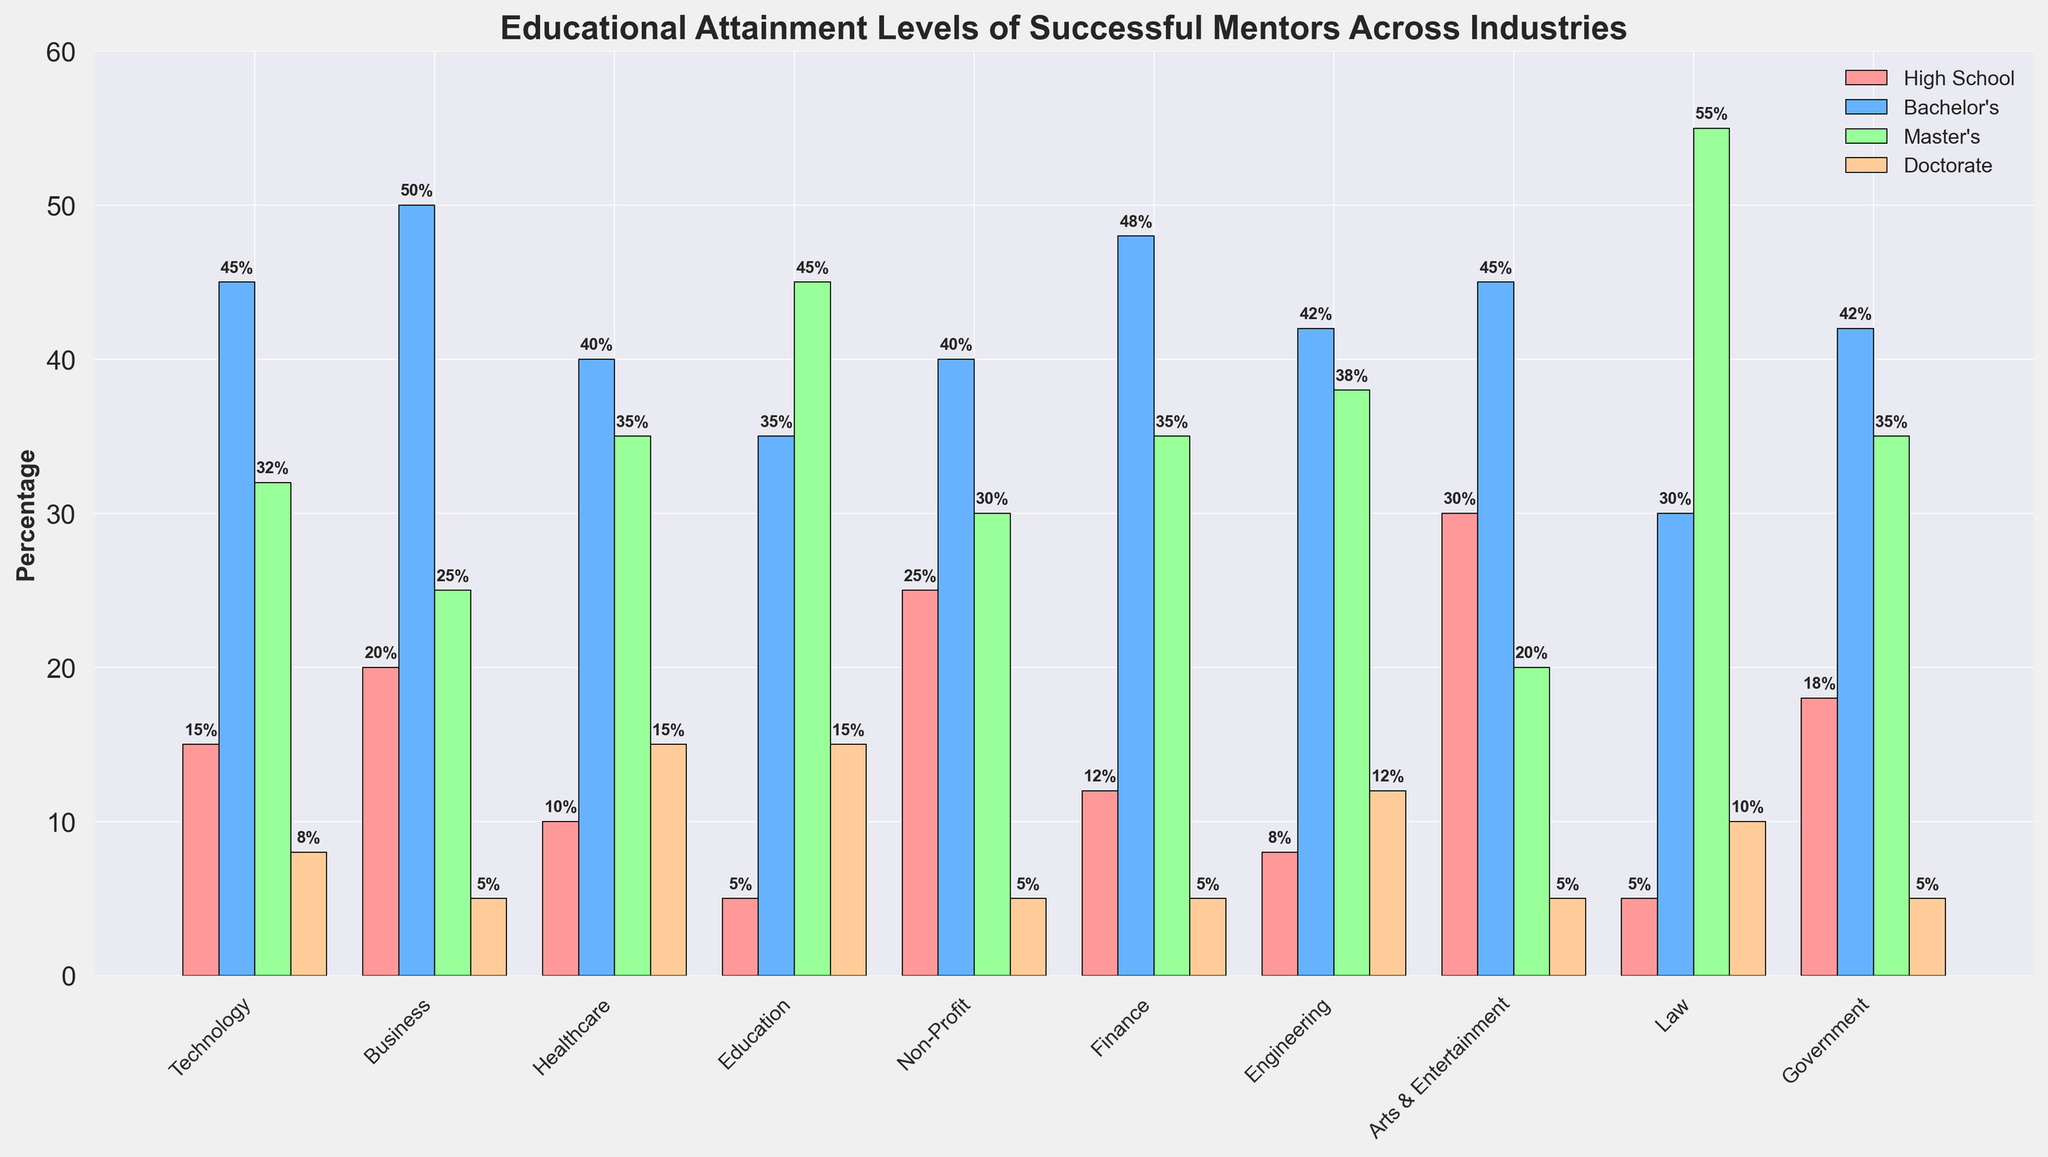Which industry has the highest percentage of mentors with a Master's degree? Look at the green bars, which represent Master's degree percentages, and compare the heights of these bars across different industries. The Education industry has the highest bar for Master's degree at 45%.
Answer: Education What is the sum of Bachelor's degree percentages in Technology and Finance? Identify the blue bars that represent Bachelor's degree for Technology and Finance. Sum these two values: 45% (Technology) + 48% (Finance) = 93%.
Answer: 93% Which industry has the lowest percentage of mentors with a High School education? Look at the red bars representing High School percentages and find the shortest bar. The Law industry has the lowest at 5%.
Answer: Law Are there more mentors with Doctorates in Healthcare or Engineering? Compare the orange bars representing Doctorate degrees for both Healthcare (15%) and Engineering (12%). Healthcare has a higher percentage.
Answer: Healthcare What is the average percentage of mentors with a Master's degree across all industries? Add the percentages for Master's degrees in all industries and divide by the number of industries. (32 + 25 + 35 + 45 + 30 + 35 + 38 + 20 + 55 + 35)/10 = 35%.
Answer: 35% Which industries have equal percentages of mentors with a high school education? Find the red bars that have the same height. Business and Finance both have a High School percentage of 20%.
Answer: Business and Finance For the Technology and Government industries, which education level has the greatest difference in percentage? Calculate the differences for each education level between Technology and Government: High School (15 - 18 = -3%), Bachelor's (45 - 42 = 3%), Master's (32 - 35 = -3%), Doctorate (8 - 5 = 3%). The Bachelor's and Doctorate levels both show the greatest difference (3%).
Answer: Bachelor’s and Doctorate What is the total percentage of mentors with a Bachelor's degree in Non-Profit, Arts & Entertainment, and Law industries? Add the Bachelor's degree percentages for these industries: 40% (Non-Profit) + 45% (Arts & Entertainment) + 30% (Law) = 115%.
Answer: 115% Does any industry have a majority (more than 50%) of mentors with a specific education level? Scan the bars for any education level's percentage that exceeds 50%. The Law industry has more than 50% of mentors with a Master's degree (55%).
Answer: Law 